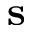<formula> <loc_0><loc_0><loc_500><loc_500>s</formula> 